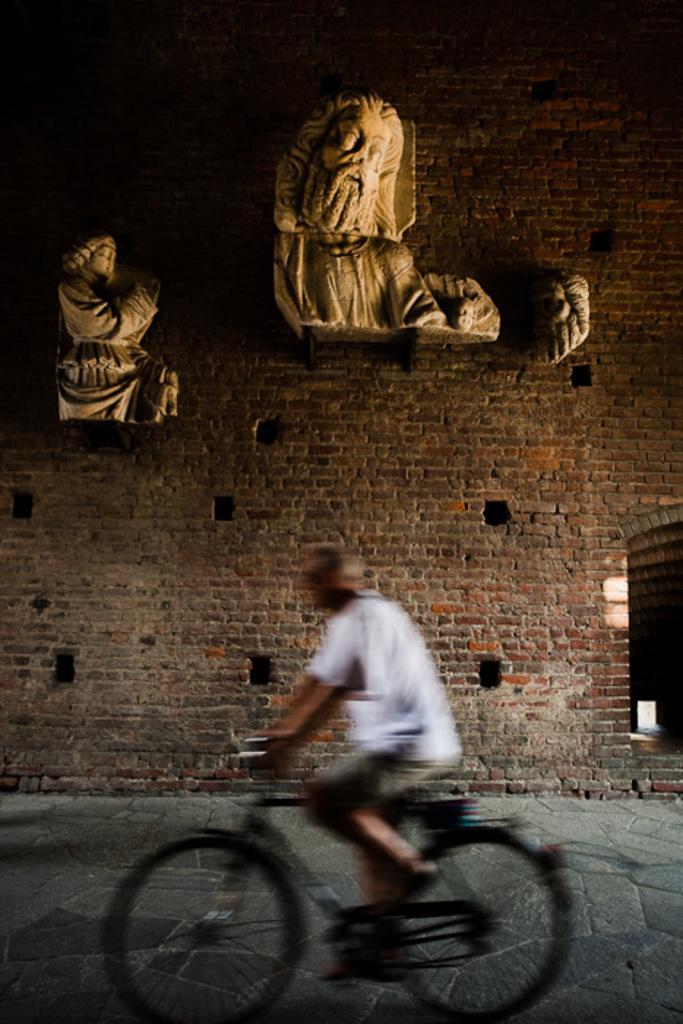Can you describe this image briefly? a person is wearing a white t shirt and riding a black bicycle. behind him there is a brick wall on which there are 2 sculptures. there are holes in the wall. 